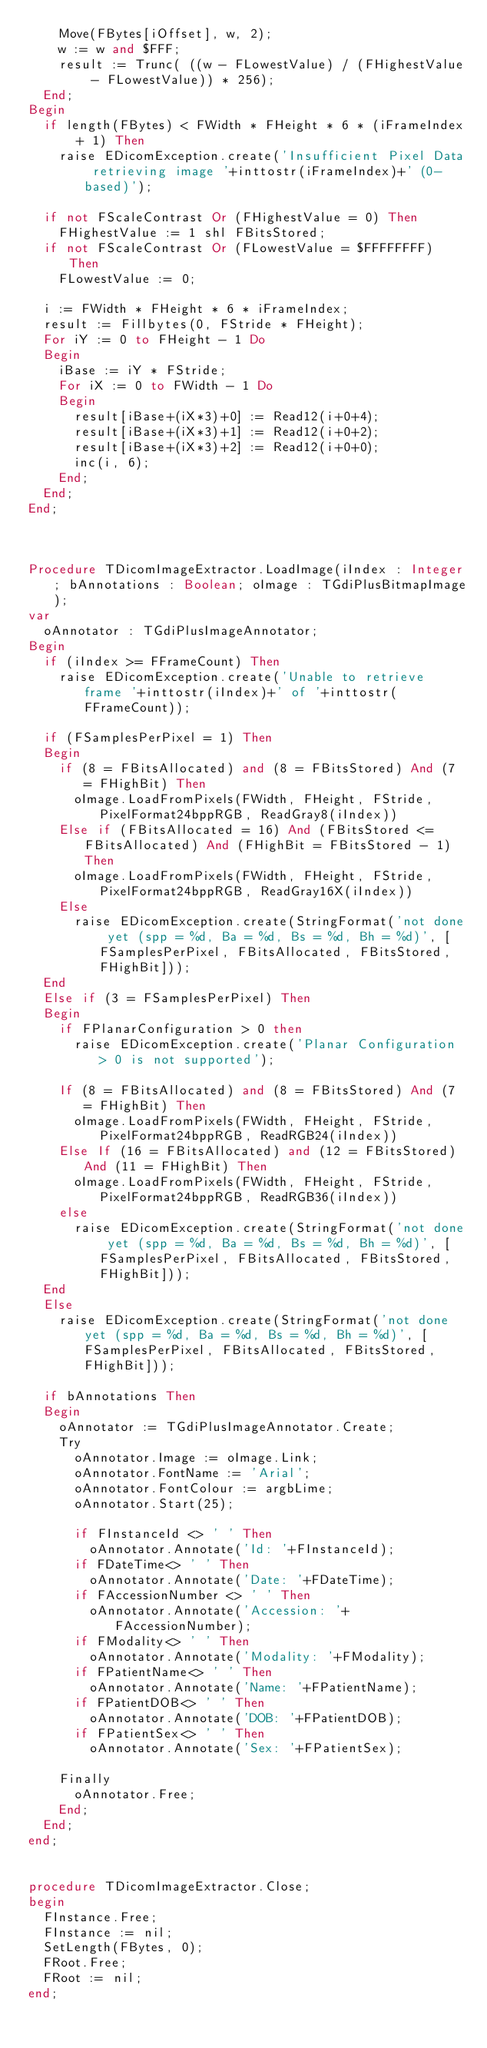Convert code to text. <code><loc_0><loc_0><loc_500><loc_500><_Pascal_>    Move(FBytes[iOffset], w, 2);
    w := w and $FFF;
    result := Trunc( ((w - FLowestValue) / (FHighestValue - FLowestValue)) * 256);
  End;
Begin
  if length(FBytes) < FWidth * FHeight * 6 * (iFrameIndex + 1) Then
    raise EDicomException.create('Insufficient Pixel Data retrieving image '+inttostr(iFrameIndex)+' (0-based)');

  if not FScaleContrast Or (FHighestValue = 0) Then
    FHighestValue := 1 shl FBitsStored;
  if not FScaleContrast Or (FLowestValue = $FFFFFFFF) Then
    FLowestValue := 0;

  i := FWidth * FHeight * 6 * iFrameIndex;
  result := Fillbytes(0, FStride * FHeight);
  For iY := 0 to FHeight - 1 Do
  Begin
    iBase := iY * FStride;
    For iX := 0 to FWidth - 1 Do
    Begin
      result[iBase+(iX*3)+0] := Read12(i+0+4);
      result[iBase+(iX*3)+1] := Read12(i+0+2);
      result[iBase+(iX*3)+2] := Read12(i+0+0);
      inc(i, 6);
    End;
  End;
End;



Procedure TDicomImageExtractor.LoadImage(iIndex : Integer; bAnnotations : Boolean; oImage : TGdiPlusBitmapImage);
var
  oAnnotator : TGdiPlusImageAnnotator;
Begin
  if (iIndex >= FFrameCount) Then
    raise EDicomException.create('Unable to retrieve frame '+inttostr(iIndex)+' of '+inttostr(FFrameCount));

  if (FSamplesPerPixel = 1) Then
  Begin
    if (8 = FBitsAllocated) and (8 = FBitsStored) And (7 = FHighBit) Then
      oImage.LoadFromPixels(FWidth, FHeight, FStride, PixelFormat24bppRGB, ReadGray8(iIndex))
    Else if (FBitsAllocated = 16) And (FBitsStored <= FBitsAllocated) And (FHighBit = FBitsStored - 1)  Then
      oImage.LoadFromPixels(FWidth, FHeight, FStride, PixelFormat24bppRGB, ReadGray16X(iIndex))
    Else
      raise EDicomException.create(StringFormat('not done yet (spp = %d, Ba = %d, Bs = %d, Bh = %d)', [FSamplesPerPixel, FBitsAllocated, FBitsStored, FHighBit]));
  End
  Else if (3 = FSamplesPerPixel) Then
  Begin
    if FPlanarConfiguration > 0 then
      raise EDicomException.create('Planar Configuration > 0 is not supported');

    If (8 = FBitsAllocated) and (8 = FBitsStored) And (7 = FHighBit) Then
      oImage.LoadFromPixels(FWidth, FHeight, FStride, PixelFormat24bppRGB, ReadRGB24(iIndex))
    Else If (16 = FBitsAllocated) and (12 = FBitsStored) And (11 = FHighBit) Then
      oImage.LoadFromPixels(FWidth, FHeight, FStride, PixelFormat24bppRGB, ReadRGB36(iIndex))
    else
      raise EDicomException.create(StringFormat('not done yet (spp = %d, Ba = %d, Bs = %d, Bh = %d)', [FSamplesPerPixel, FBitsAllocated, FBitsStored, FHighBit]));
  End
  Else
    raise EDicomException.create(StringFormat('not done yet (spp = %d, Ba = %d, Bs = %d, Bh = %d)', [FSamplesPerPixel, FBitsAllocated, FBitsStored, FHighBit]));

  if bAnnotations Then
  Begin
    oAnnotator := TGdiPlusImageAnnotator.Create;
    Try
      oAnnotator.Image := oImage.Link;
      oAnnotator.FontName := 'Arial';
      oAnnotator.FontColour := argbLime;
      oAnnotator.Start(25);

      if FInstanceId <> ' ' Then
        oAnnotator.Annotate('Id: '+FInstanceId);
      if FDateTime<> ' ' Then
        oAnnotator.Annotate('Date: '+FDateTime);
      if FAccessionNumber <> ' ' Then
        oAnnotator.Annotate('Accession: '+FAccessionNumber);
      if FModality<> ' ' Then
        oAnnotator.Annotate('Modality: '+FModality);
      if FPatientName<> ' ' Then
        oAnnotator.Annotate('Name: '+FPatientName);
      if FPatientDOB<> ' ' Then
        oAnnotator.Annotate('DOB: '+FPatientDOB);
      if FPatientSex<> ' ' Then
        oAnnotator.Annotate('Sex: '+FPatientSex);

    Finally
      oAnnotator.Free;
    End;
  End;
end;


procedure TDicomImageExtractor.Close;
begin
  FInstance.Free;
  FInstance := nil;
  SetLength(FBytes, 0);
  FRoot.Free;
  FRoot := nil;
end;
</code> 